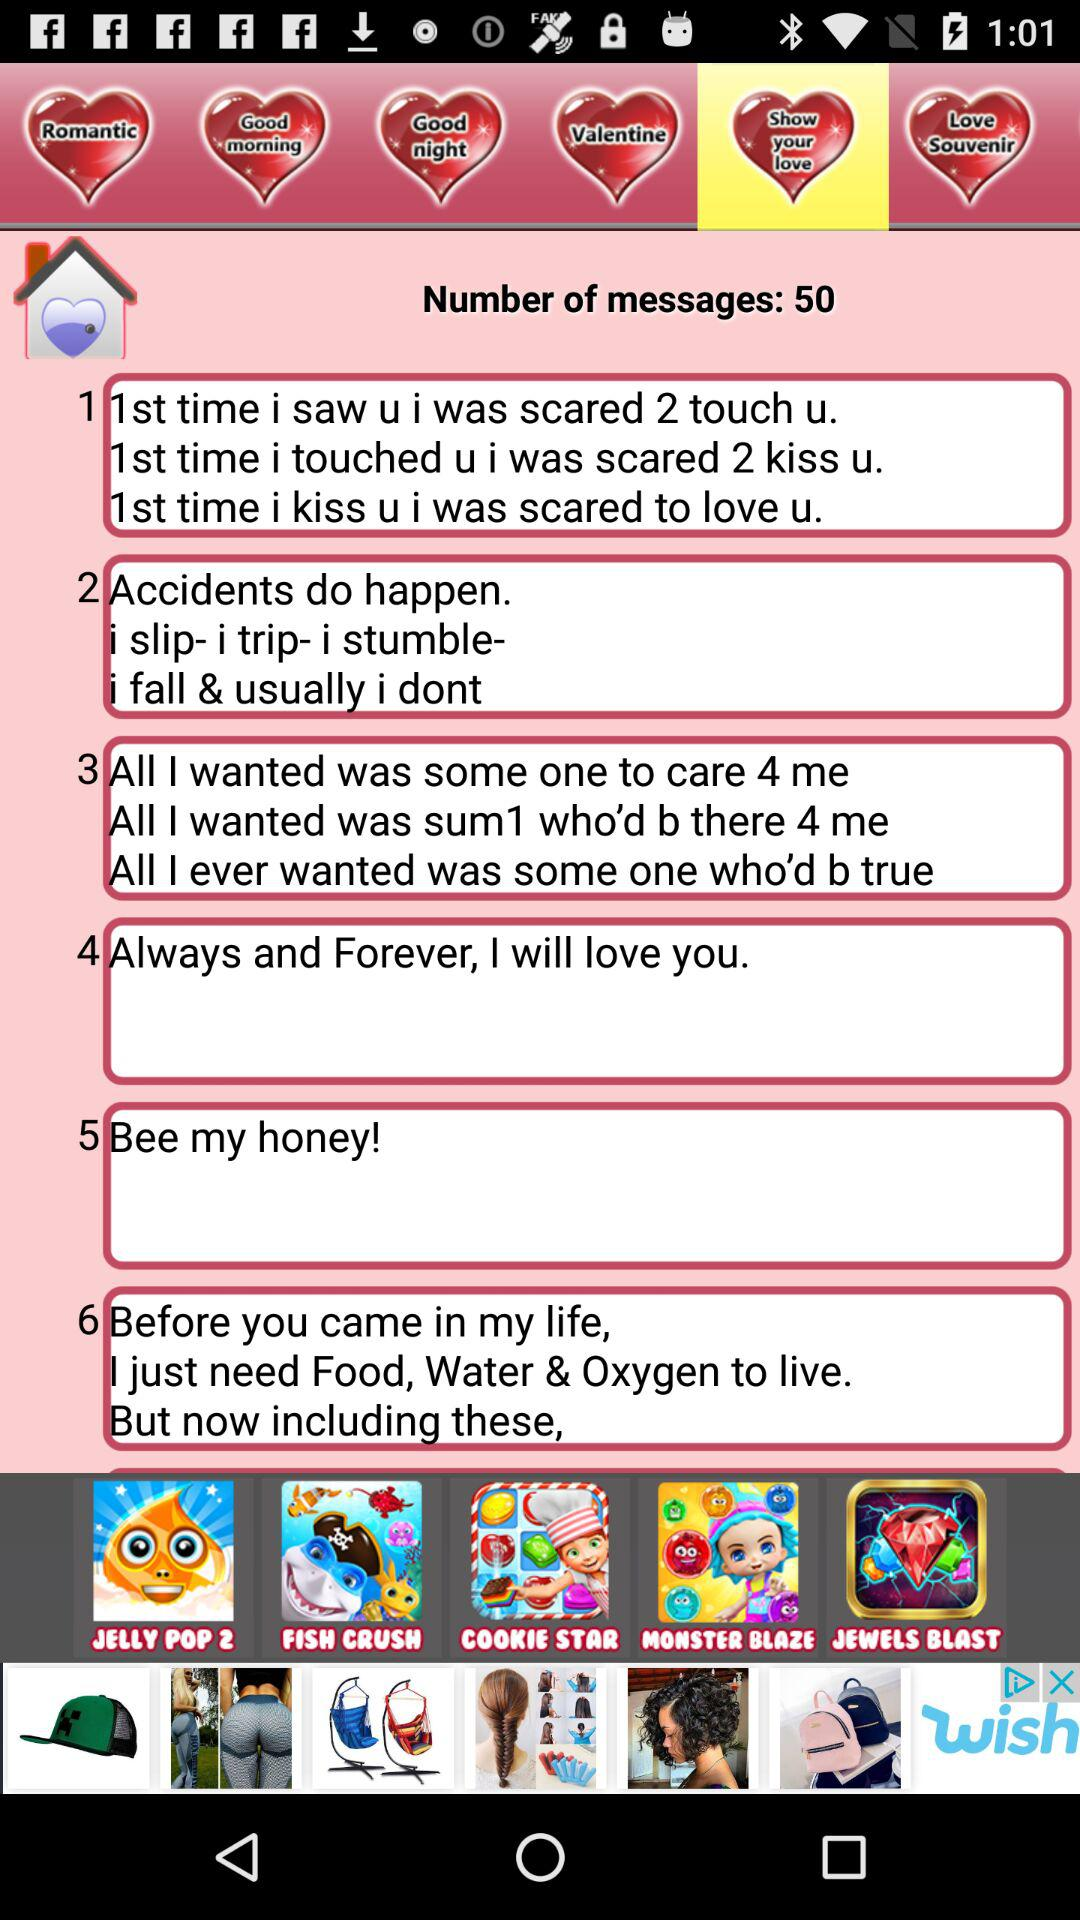What is the total number of messages? The total number of messages is 50. 